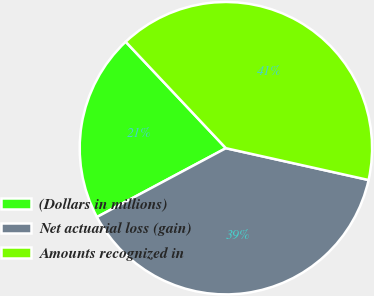<chart> <loc_0><loc_0><loc_500><loc_500><pie_chart><fcel>(Dollars in millions)<fcel>Net actuarial loss (gain)<fcel>Amounts recognized in<nl><fcel>20.78%<fcel>38.7%<fcel>40.51%<nl></chart> 